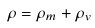Convert formula to latex. <formula><loc_0><loc_0><loc_500><loc_500>\rho = \rho _ { m } + \rho _ { v }</formula> 